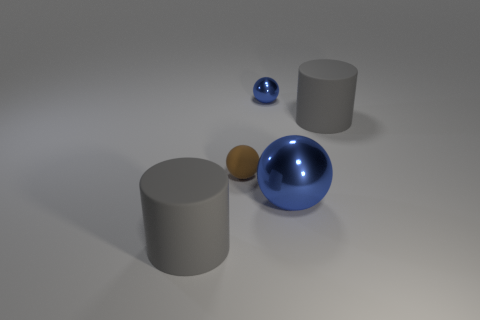Subtract all tiny matte spheres. How many spheres are left? 2 Subtract all gray blocks. How many blue spheres are left? 2 Add 4 tiny blue metal objects. How many objects exist? 9 Subtract all balls. How many objects are left? 2 Subtract all gray balls. Subtract all purple cubes. How many balls are left? 3 Subtract 0 green cubes. How many objects are left? 5 Subtract all small rubber spheres. Subtract all small things. How many objects are left? 2 Add 1 cylinders. How many cylinders are left? 3 Add 1 large gray cylinders. How many large gray cylinders exist? 3 